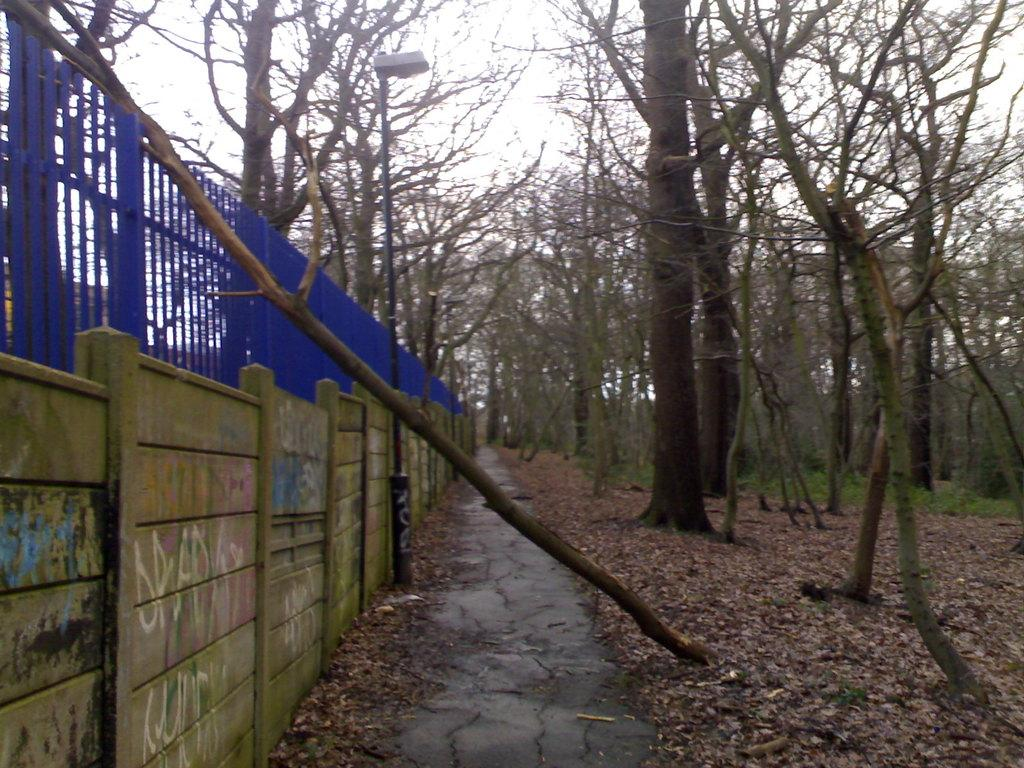What is the main feature in the center of the image? There are many trees in the center of the image. What type of man-made object can be seen in the image? There is a street light in the image. What is the purpose of the fencing in the image? The fencing in the image serves as a barrier or boundary. What type of heart can be seen beating in the image? There is no heart visible in the image; it features trees, a street light, and fencing. 